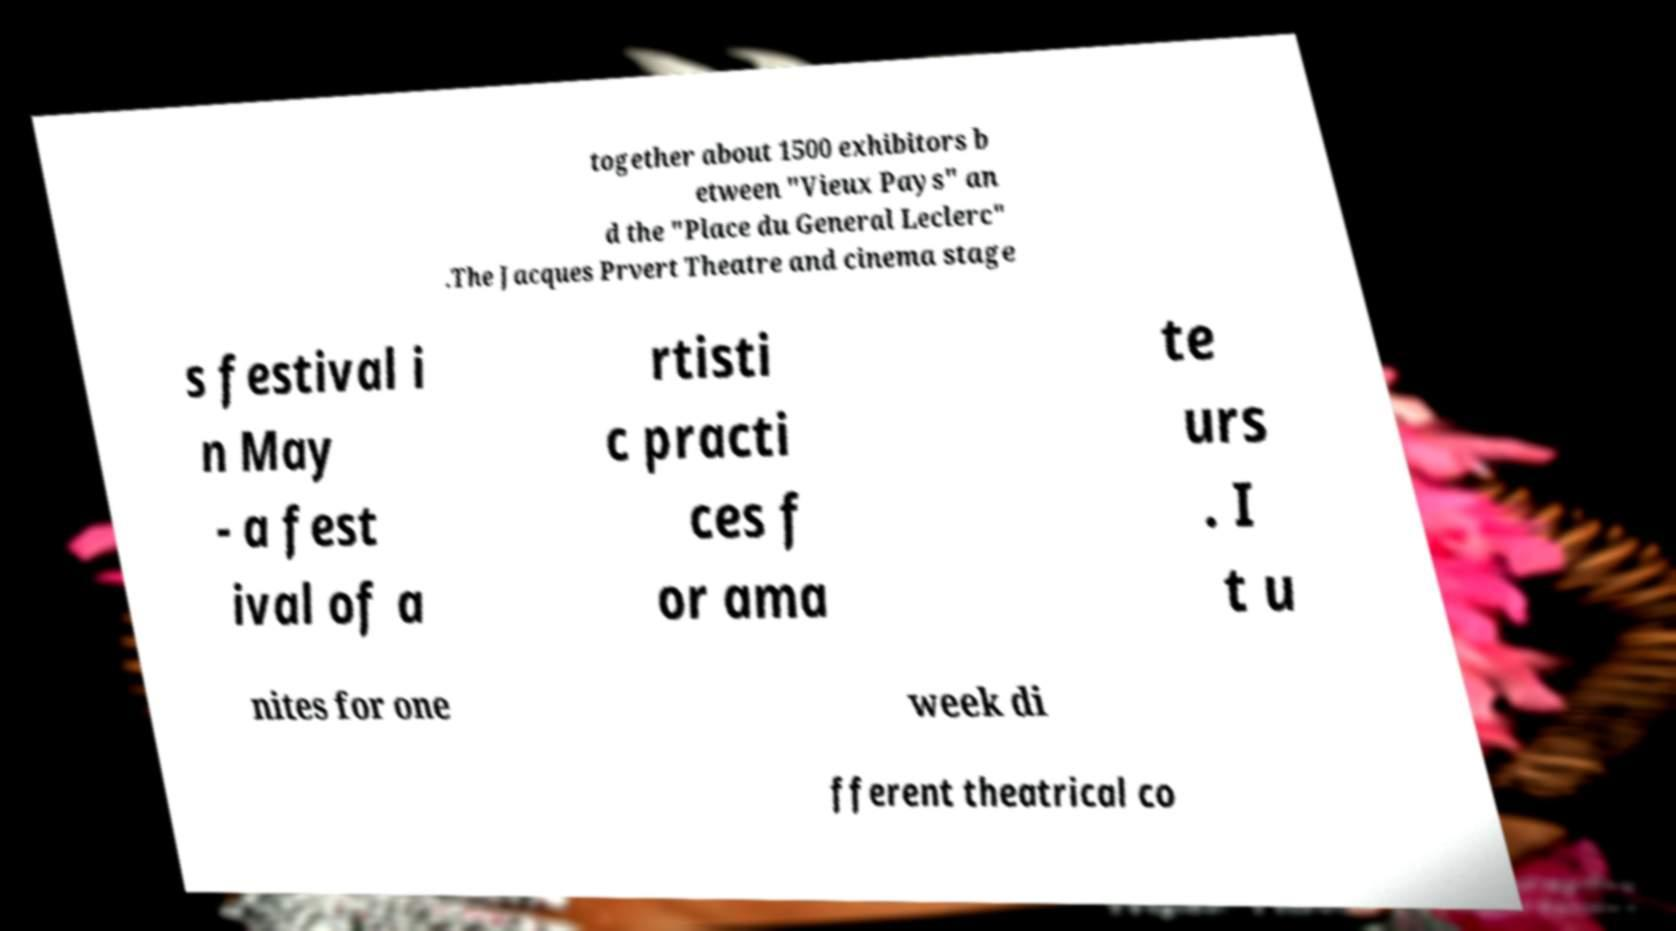Can you read and provide the text displayed in the image?This photo seems to have some interesting text. Can you extract and type it out for me? together about 1500 exhibitors b etween "Vieux Pays" an d the "Place du General Leclerc" .The Jacques Prvert Theatre and cinema stage s festival i n May - a fest ival of a rtisti c practi ces f or ama te urs . I t u nites for one week di fferent theatrical co 